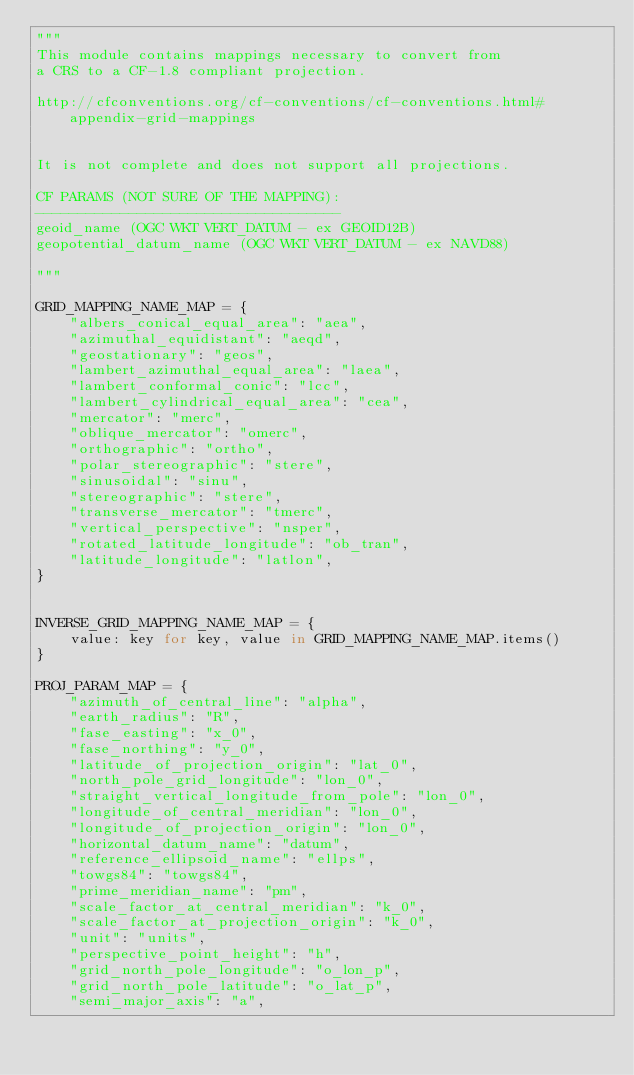Convert code to text. <code><loc_0><loc_0><loc_500><loc_500><_Python_>"""
This module contains mappings necessary to convert from
a CRS to a CF-1.8 compliant projection.

http://cfconventions.org/cf-conventions/cf-conventions.html#appendix-grid-mappings


It is not complete and does not support all projections.

CF PARAMS (NOT SURE OF THE MAPPING):
------------------------------------
geoid_name (OGC WKT VERT_DATUM - ex GEOID12B)
geopotential_datum_name (OGC WKT VERT_DATUM - ex NAVD88)

"""

GRID_MAPPING_NAME_MAP = {
    "albers_conical_equal_area": "aea",
    "azimuthal_equidistant": "aeqd",
    "geostationary": "geos",
    "lambert_azimuthal_equal_area": "laea",
    "lambert_conformal_conic": "lcc",
    "lambert_cylindrical_equal_area": "cea",
    "mercator": "merc",
    "oblique_mercator": "omerc",
    "orthographic": "ortho",
    "polar_stereographic": "stere",
    "sinusoidal": "sinu",
    "stereographic": "stere",
    "transverse_mercator": "tmerc",
    "vertical_perspective": "nsper",
    "rotated_latitude_longitude": "ob_tran",
    "latitude_longitude": "latlon",
}


INVERSE_GRID_MAPPING_NAME_MAP = {
    value: key for key, value in GRID_MAPPING_NAME_MAP.items()
}

PROJ_PARAM_MAP = {
    "azimuth_of_central_line": "alpha",
    "earth_radius": "R",
    "fase_easting": "x_0",
    "fase_northing": "y_0",
    "latitude_of_projection_origin": "lat_0",
    "north_pole_grid_longitude": "lon_0",
    "straight_vertical_longitude_from_pole": "lon_0",
    "longitude_of_central_meridian": "lon_0",
    "longitude_of_projection_origin": "lon_0",
    "horizontal_datum_name": "datum",
    "reference_ellipsoid_name": "ellps",
    "towgs84": "towgs84",
    "prime_meridian_name": "pm",
    "scale_factor_at_central_meridian": "k_0",
    "scale_factor_at_projection_origin": "k_0",
    "unit": "units",
    "perspective_point_height": "h",
    "grid_north_pole_longitude": "o_lon_p",
    "grid_north_pole_latitude": "o_lat_p",
    "semi_major_axis": "a",</code> 